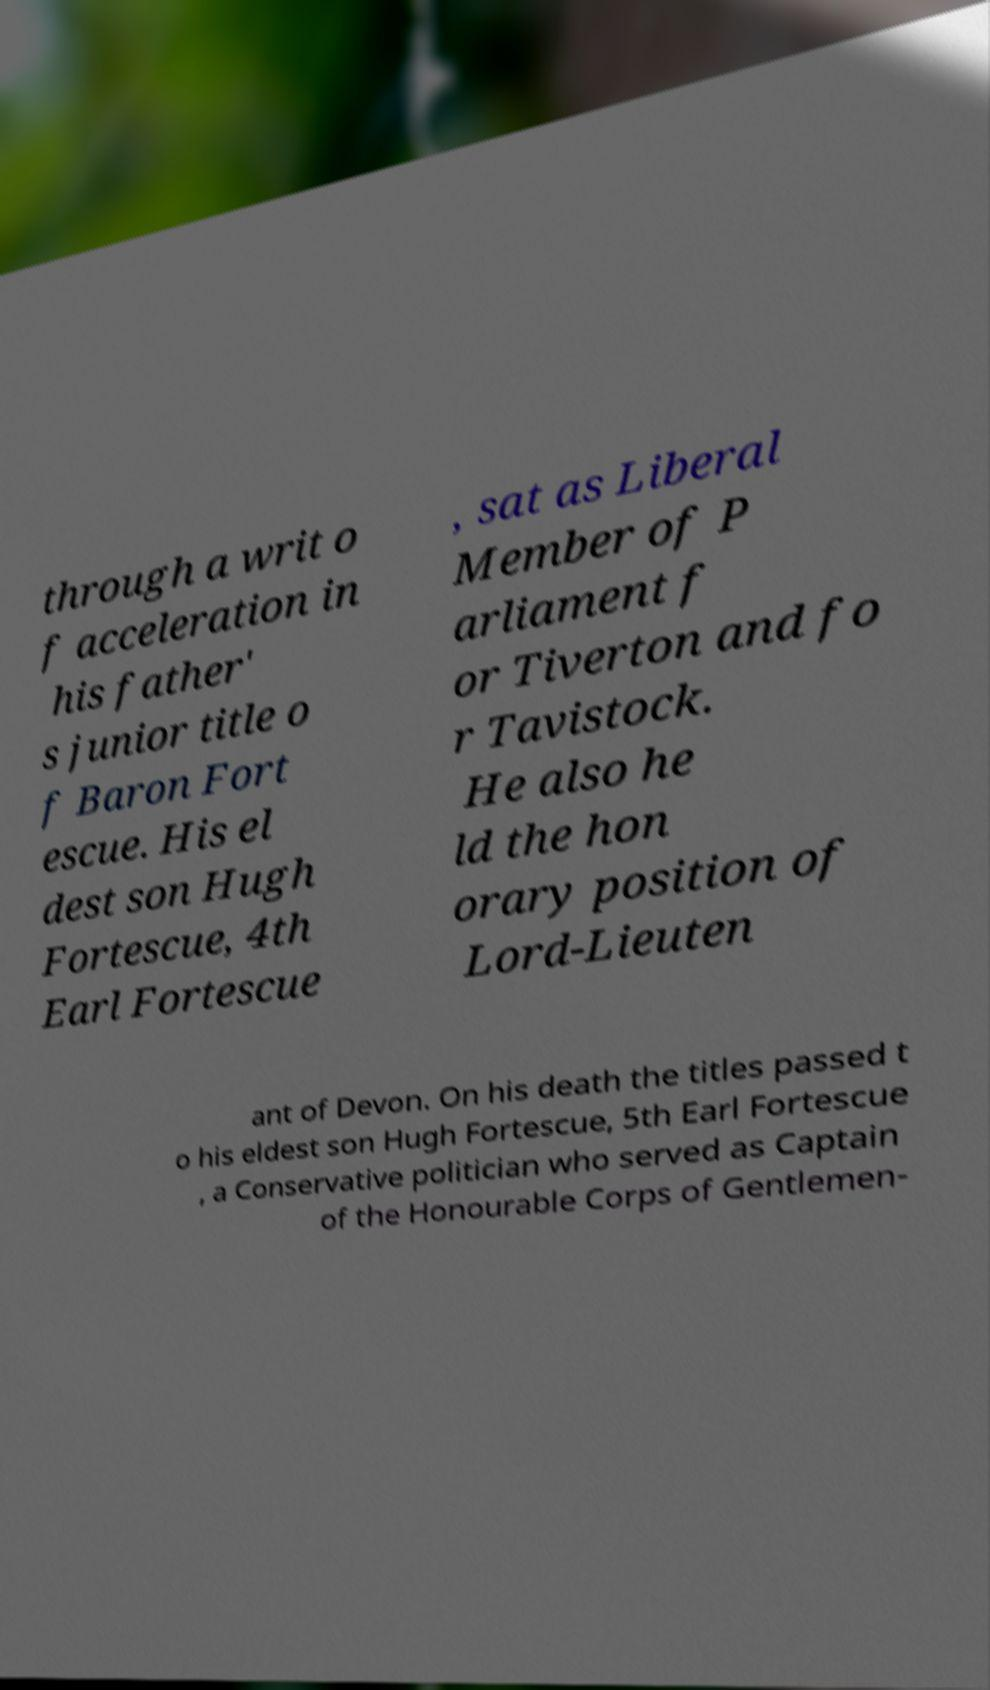There's text embedded in this image that I need extracted. Can you transcribe it verbatim? through a writ o f acceleration in his father' s junior title o f Baron Fort escue. His el dest son Hugh Fortescue, 4th Earl Fortescue , sat as Liberal Member of P arliament f or Tiverton and fo r Tavistock. He also he ld the hon orary position of Lord-Lieuten ant of Devon. On his death the titles passed t o his eldest son Hugh Fortescue, 5th Earl Fortescue , a Conservative politician who served as Captain of the Honourable Corps of Gentlemen- 